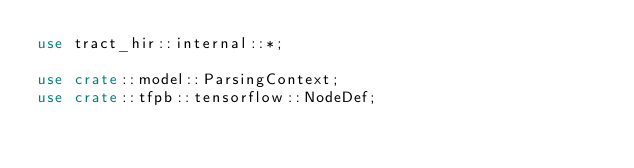<code> <loc_0><loc_0><loc_500><loc_500><_Rust_>use tract_hir::internal::*;

use crate::model::ParsingContext;
use crate::tfpb::tensorflow::NodeDef;
</code> 